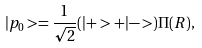<formula> <loc_0><loc_0><loc_500><loc_500>| p _ { 0 } > = \frac { 1 } { \sqrt { 2 } } ( | + > + | - > ) \Pi ( { R } ) ,</formula> 